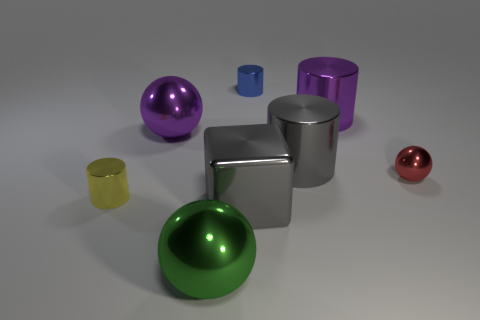Subtract 1 cylinders. How many cylinders are left? 3 Add 1 small blue cylinders. How many objects exist? 9 Subtract all spheres. How many objects are left? 5 Subtract 1 purple balls. How many objects are left? 7 Subtract all cyan metal cylinders. Subtract all big metal objects. How many objects are left? 3 Add 6 large green objects. How many large green objects are left? 7 Add 4 big cyan cylinders. How many big cyan cylinders exist? 4 